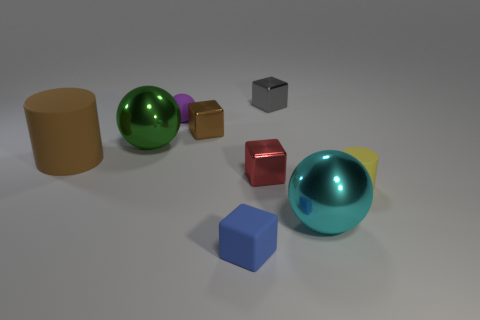How many red matte things are there?
Provide a short and direct response. 0. There is a big ball to the left of the tiny cube that is in front of the tiny object that is right of the large cyan sphere; what is it made of?
Your answer should be compact. Metal. There is a cylinder that is right of the gray metal object; how many green metallic balls are behind it?
Ensure brevity in your answer.  1. The other small matte thing that is the same shape as the tiny brown object is what color?
Provide a short and direct response. Blue. Is the material of the small gray cube the same as the small sphere?
Offer a terse response. No. What number of balls are tiny brown metal things or tiny yellow rubber things?
Make the answer very short. 0. There is a rubber cylinder that is left of the big shiny ball that is behind the metallic cube that is in front of the brown matte object; how big is it?
Make the answer very short. Large. There is a brown object that is the same shape as the red thing; what is its size?
Provide a succinct answer. Small. How many large cyan balls are on the right side of the tiny cylinder?
Your answer should be very brief. 0. There is a metallic object to the right of the gray thing; does it have the same color as the small rubber cylinder?
Your answer should be compact. No. 